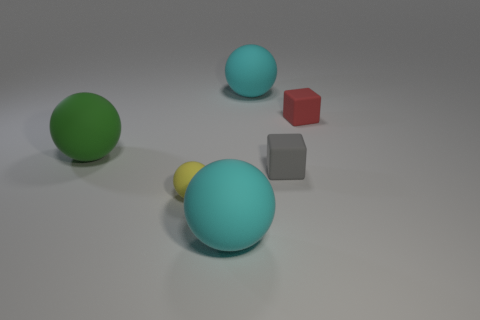Subtract all blue spheres. Subtract all cyan cylinders. How many spheres are left? 4 Add 3 spheres. How many objects exist? 9 Subtract all blocks. How many objects are left? 4 Subtract all small yellow objects. Subtract all tiny red matte things. How many objects are left? 4 Add 2 blocks. How many blocks are left? 4 Add 3 spheres. How many spheres exist? 7 Subtract 0 red spheres. How many objects are left? 6 